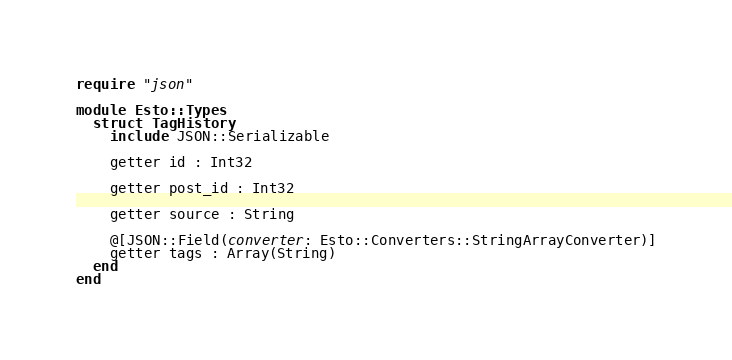<code> <loc_0><loc_0><loc_500><loc_500><_Crystal_>require "json"

module Esto::Types
  struct TagHistory
    include JSON::Serializable

    getter id : Int32

    getter post_id : Int32

    getter source : String

    @[JSON::Field(converter: Esto::Converters::StringArrayConverter)]
    getter tags : Array(String)
  end
end
</code> 